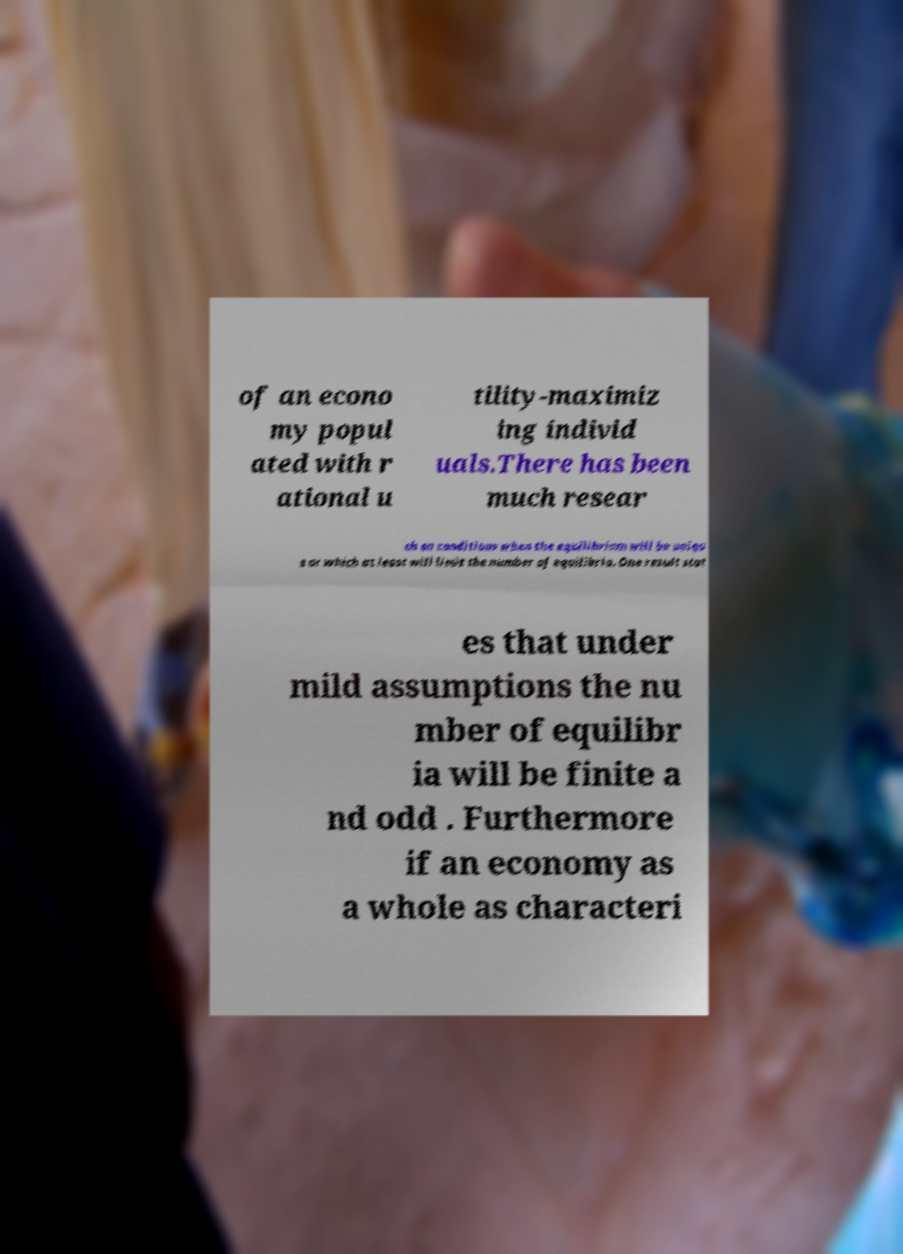What messages or text are displayed in this image? I need them in a readable, typed format. of an econo my popul ated with r ational u tility-maximiz ing individ uals.There has been much resear ch on conditions when the equilibrium will be uniqu e or which at least will limit the number of equilibria. One result stat es that under mild assumptions the nu mber of equilibr ia will be finite a nd odd . Furthermore if an economy as a whole as characteri 